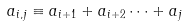<formula> <loc_0><loc_0><loc_500><loc_500>a _ { i , j } \equiv a _ { i + 1 } + a _ { i + 2 } \dots + a _ { j }</formula> 